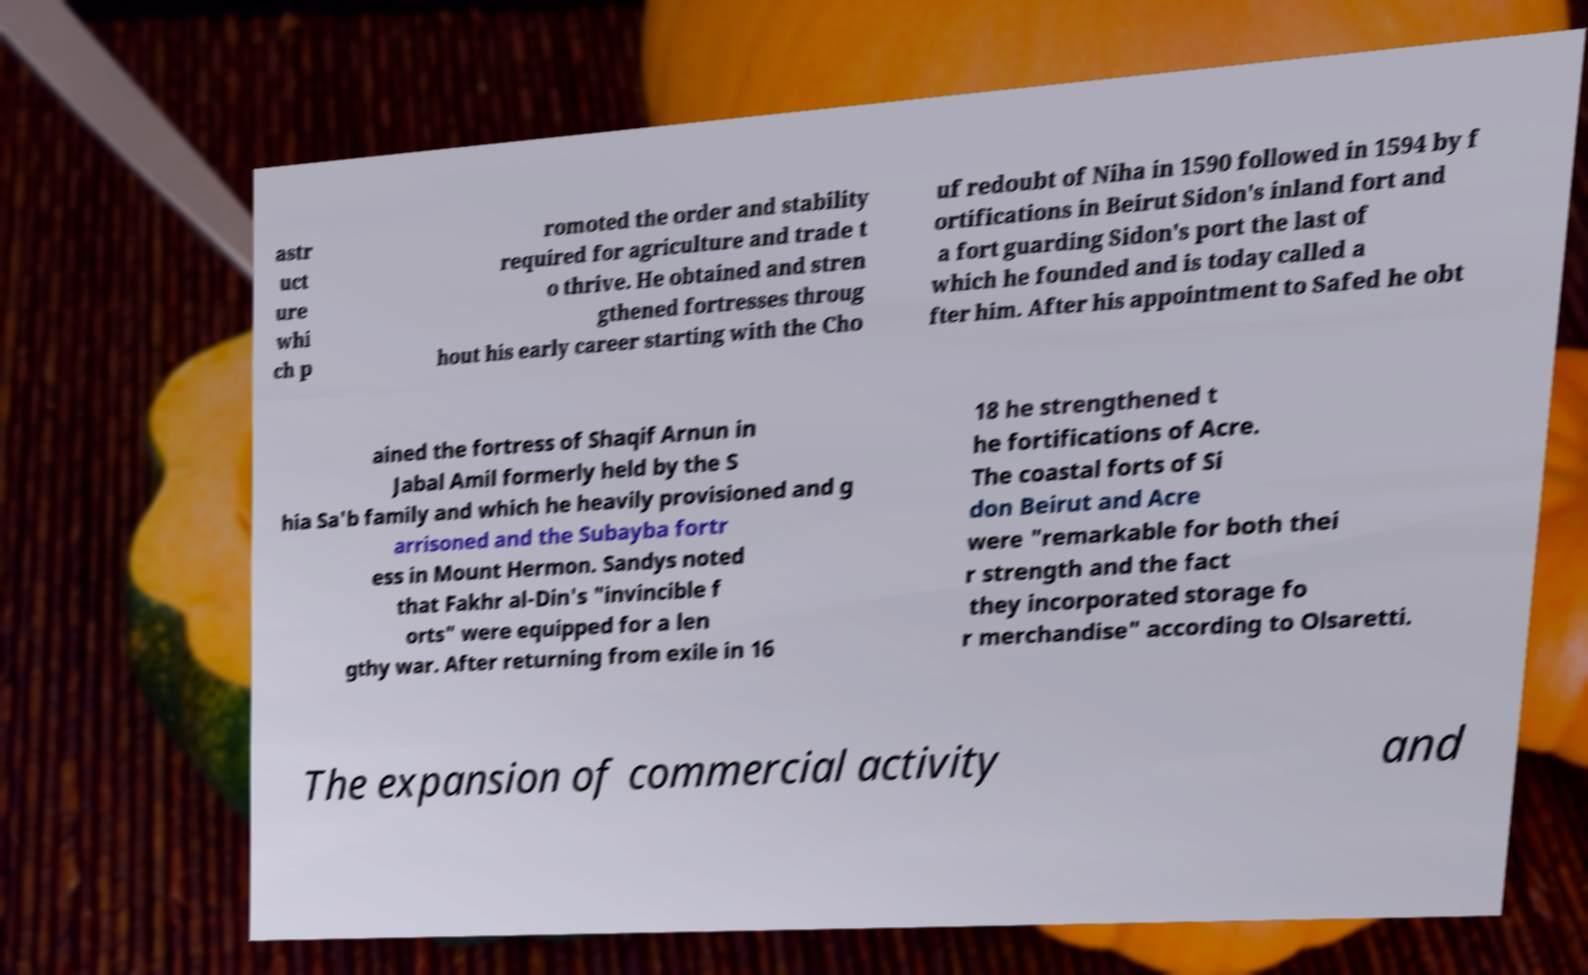Can you read and provide the text displayed in the image?This photo seems to have some interesting text. Can you extract and type it out for me? astr uct ure whi ch p romoted the order and stability required for agriculture and trade t o thrive. He obtained and stren gthened fortresses throug hout his early career starting with the Cho uf redoubt of Niha in 1590 followed in 1594 by f ortifications in Beirut Sidon's inland fort and a fort guarding Sidon's port the last of which he founded and is today called a fter him. After his appointment to Safed he obt ained the fortress of Shaqif Arnun in Jabal Amil formerly held by the S hia Sa'b family and which he heavily provisioned and g arrisoned and the Subayba fortr ess in Mount Hermon. Sandys noted that Fakhr al-Din's "invincible f orts" were equipped for a len gthy war. After returning from exile in 16 18 he strengthened t he fortifications of Acre. The coastal forts of Si don Beirut and Acre were "remarkable for both thei r strength and the fact they incorporated storage fo r merchandise" according to Olsaretti. The expansion of commercial activity and 